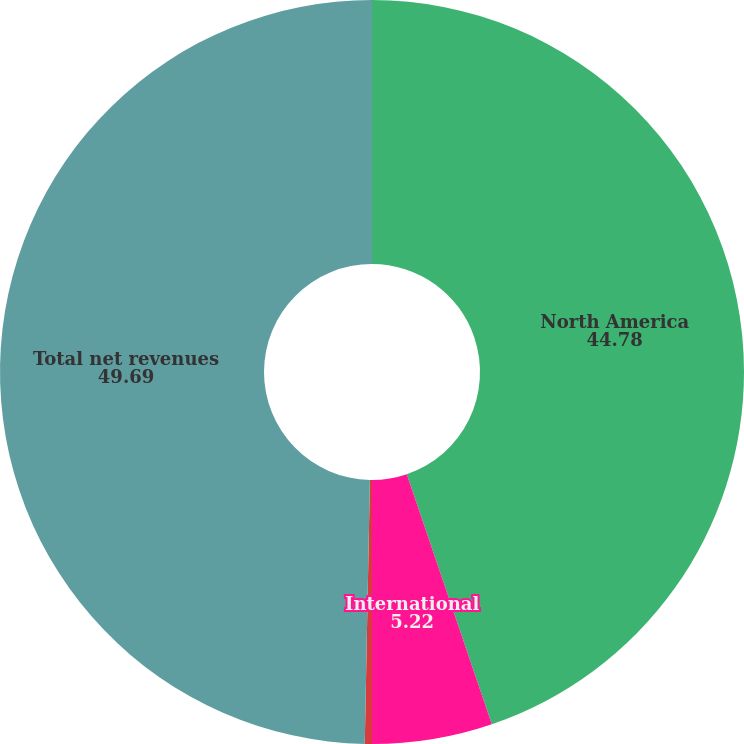<chart> <loc_0><loc_0><loc_500><loc_500><pie_chart><fcel>North America<fcel>International<fcel>Connected Fitness<fcel>Total net revenues<nl><fcel>44.78%<fcel>5.22%<fcel>0.31%<fcel>49.69%<nl></chart> 